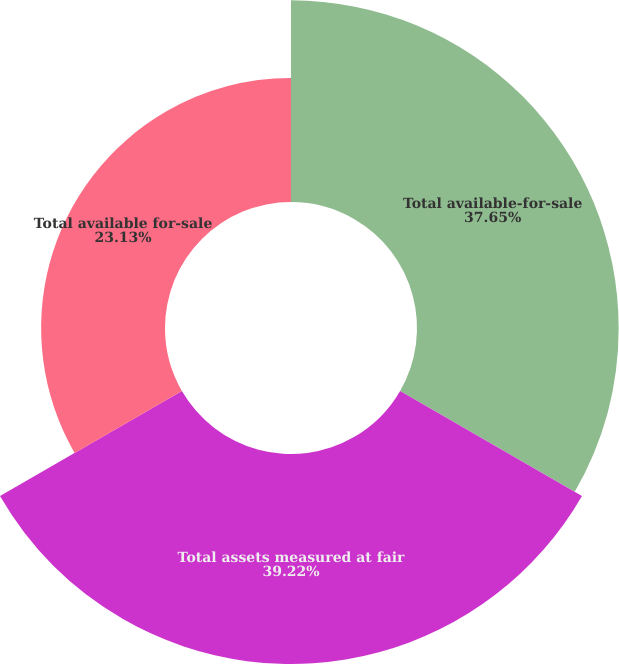<chart> <loc_0><loc_0><loc_500><loc_500><pie_chart><fcel>Total available-for-sale<fcel>Total assets measured at fair<fcel>Total available for-sale<nl><fcel>37.65%<fcel>39.21%<fcel>23.13%<nl></chart> 